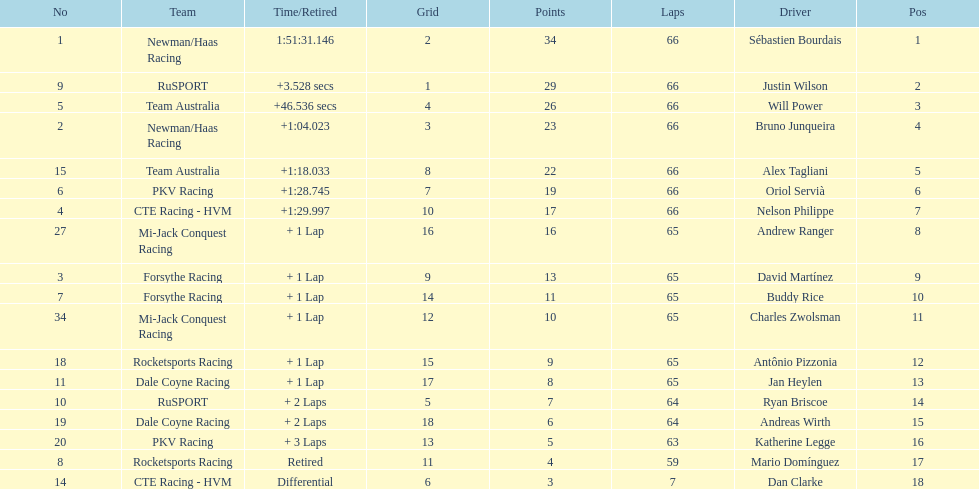What is the number of laps dan clarke completed? 7. Would you mind parsing the complete table? {'header': ['No', 'Team', 'Time/Retired', 'Grid', 'Points', 'Laps', 'Driver', 'Pos'], 'rows': [['1', 'Newman/Haas Racing', '1:51:31.146', '2', '34', '66', 'Sébastien Bourdais', '1'], ['9', 'RuSPORT', '+3.528 secs', '1', '29', '66', 'Justin Wilson', '2'], ['5', 'Team Australia', '+46.536 secs', '4', '26', '66', 'Will Power', '3'], ['2', 'Newman/Haas Racing', '+1:04.023', '3', '23', '66', 'Bruno Junqueira', '4'], ['15', 'Team Australia', '+1:18.033', '8', '22', '66', 'Alex Tagliani', '5'], ['6', 'PKV Racing', '+1:28.745', '7', '19', '66', 'Oriol Servià', '6'], ['4', 'CTE Racing - HVM', '+1:29.997', '10', '17', '66', 'Nelson Philippe', '7'], ['27', 'Mi-Jack Conquest Racing', '+ 1 Lap', '16', '16', '65', 'Andrew Ranger', '8'], ['3', 'Forsythe Racing', '+ 1 Lap', '9', '13', '65', 'David Martínez', '9'], ['7', 'Forsythe Racing', '+ 1 Lap', '14', '11', '65', 'Buddy Rice', '10'], ['34', 'Mi-Jack Conquest Racing', '+ 1 Lap', '12', '10', '65', 'Charles Zwolsman', '11'], ['18', 'Rocketsports Racing', '+ 1 Lap', '15', '9', '65', 'Antônio Pizzonia', '12'], ['11', 'Dale Coyne Racing', '+ 1 Lap', '17', '8', '65', 'Jan Heylen', '13'], ['10', 'RuSPORT', '+ 2 Laps', '5', '7', '64', 'Ryan Briscoe', '14'], ['19', 'Dale Coyne Racing', '+ 2 Laps', '18', '6', '64', 'Andreas Wirth', '15'], ['20', 'PKV Racing', '+ 3 Laps', '13', '5', '63', 'Katherine Legge', '16'], ['8', 'Rocketsports Racing', 'Retired', '11', '4', '59', 'Mario Domínguez', '17'], ['14', 'CTE Racing - HVM', 'Differential', '6', '3', '7', 'Dan Clarke', '18']]} 